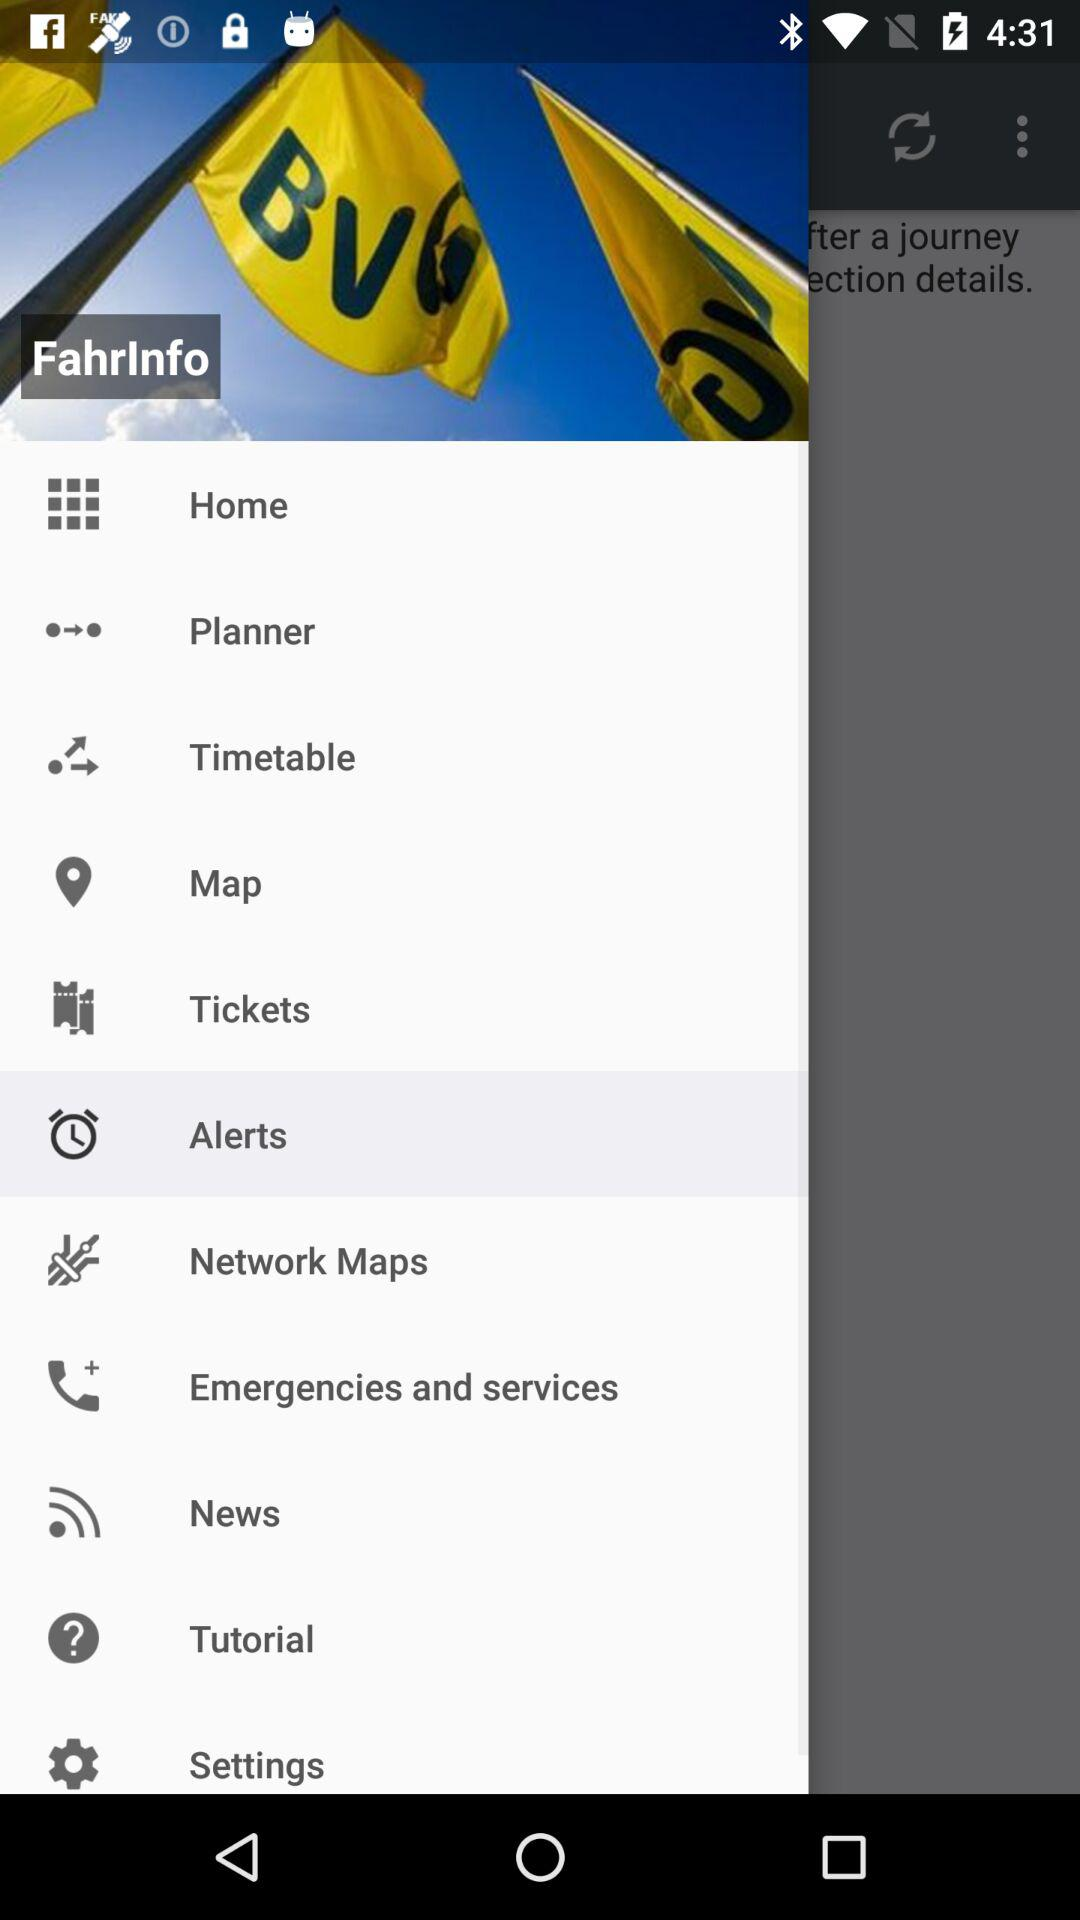What is the application name? The application name is "FahrInfo". 